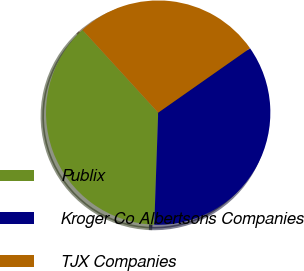Convert chart to OTSL. <chart><loc_0><loc_0><loc_500><loc_500><pie_chart><fcel>Publix<fcel>Kroger Co Albertsons Companies<fcel>TJX Companies<nl><fcel>37.65%<fcel>35.29%<fcel>27.06%<nl></chart> 